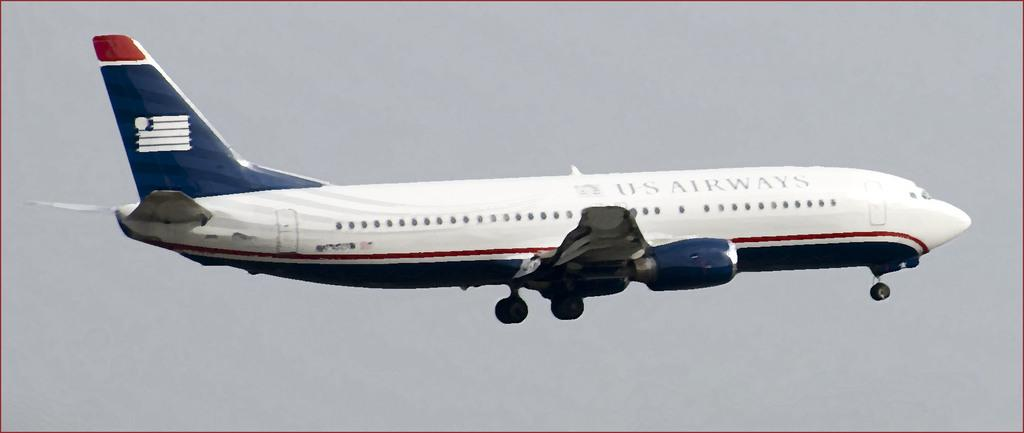What is the main subject of the image? The main subject of the image is an airplane. What is the airplane doing in the image? The airplane is flying in the air. What can be seen on the walls of the airplane? There is text on the walls of the airplane. What is visible in the background of the image? The sky is visible in the background of the image. Can you hear the boys laughing while playing with the toy in the image? There are no boys or toys present in the image; it features an airplane flying in the sky. 